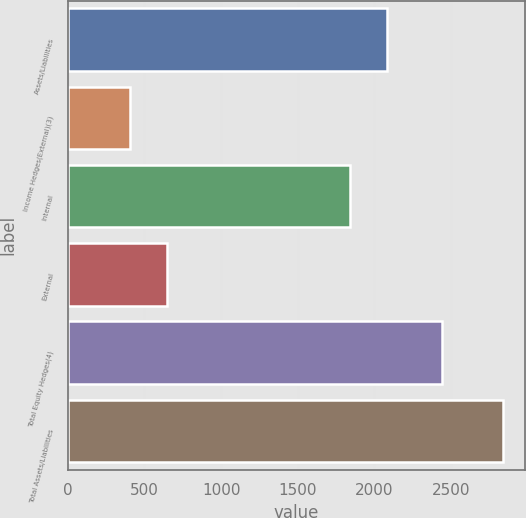<chart> <loc_0><loc_0><loc_500><loc_500><bar_chart><fcel>Assets/Liabilities<fcel>Income Hedges(External)(3)<fcel>Internal<fcel>External<fcel>Total Equity Hedges(4)<fcel>Total Assets/Liabilities<nl><fcel>2084.8<fcel>404<fcel>1841<fcel>647.8<fcel>2438<fcel>2842<nl></chart> 